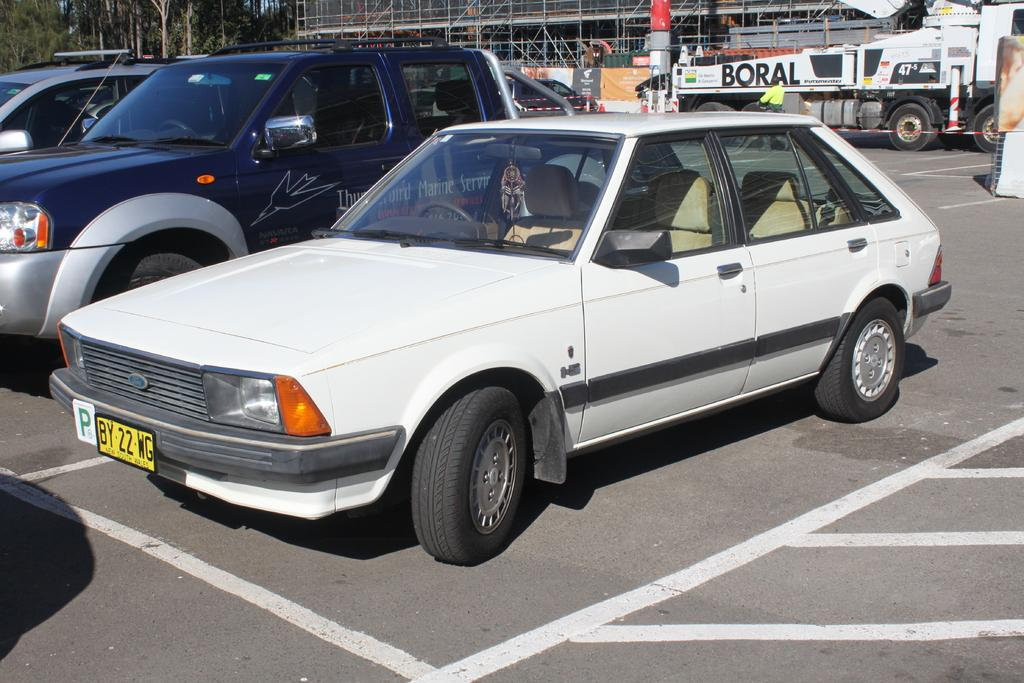What types of vehicles can be seen in the foreground of the image? There are cars in the foreground of the image. What else can be identified as vehicles in the image? There are other vehicles in the image. What is visible in the background of the image? There is a building structure, trees, and the sky visible in the background of the image. What type of plate is being used by the squirrel in the image? There is no squirrel present in the image, and therefore no plate can be associated with it. 